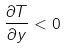<formula> <loc_0><loc_0><loc_500><loc_500>\frac { \partial T } { \partial y } < 0</formula> 